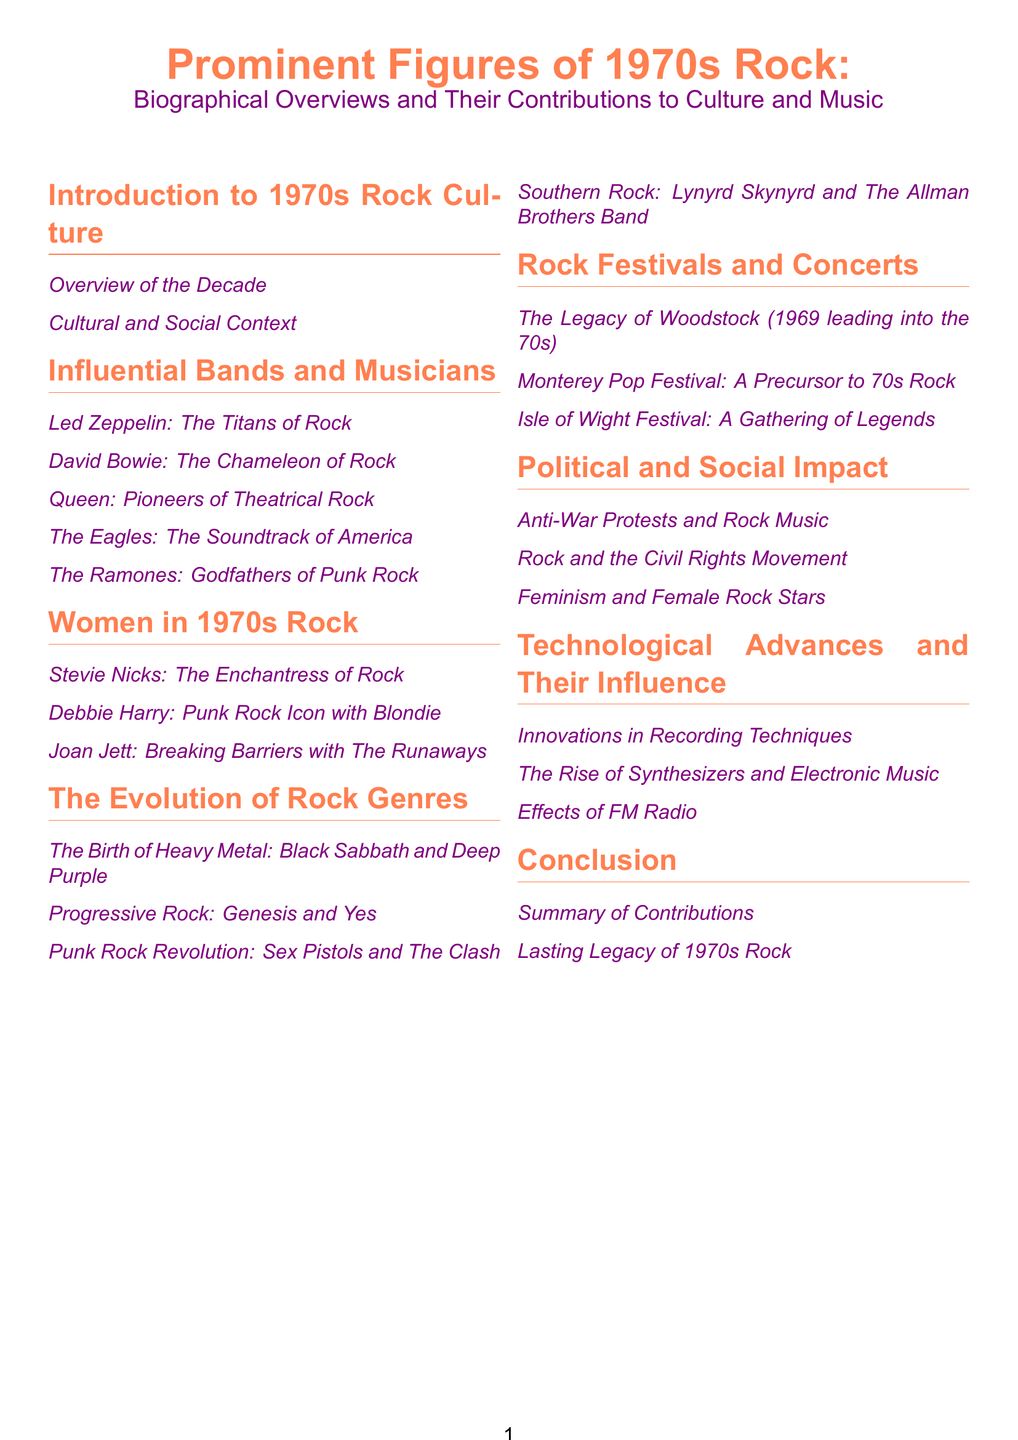What is the title of the document? The title is prominently mentioned in the document's header, which is "Prominent Figures of 1970s Rock."
Answer: Prominent Figures of 1970s Rock Who is considered the "Chameleon of Rock"? The subtitle under the influential musicians section indicates that David Bowie is referred to as the "Chameleon of Rock."
Answer: David Bowie Which band is noted for being "Pioneers of Theatrical Rock"? The document provides a section title indicating Queen is recognized as "Pioneers of Theatrical Rock."
Answer: Queen How many sections are there in the document? By counting the main sections listed in the Table of Contents, we find there are eight sections.
Answer: Eight What is the focus of the section titled "Political and Social Impact"? The subtopics under this section collectively address key societal themes associated with rock music, specifically protests and movements.
Answer: Anti-War Protests and Rock Music Which genre is associated with Black Sabbath and Deep Purple? This detail is specifically mentioned within the Evolution of Rock Genres section regarding the birth of Heavy Metal.
Answer: Heavy Metal What year does the document mention in relation to Woodstock? The document indicates that Woodstock is a legacy that extends into the 70s, explicitly referencing 1969.
Answer: 1969 Who is identified as the "Enchantress of Rock"? The document contains a specific subheading that declares Stevie Nicks this title.
Answer: Stevie Nicks 